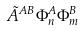<formula> <loc_0><loc_0><loc_500><loc_500>\tilde { A } ^ { A B } \Phi _ { n } ^ { A } \Phi _ { m } ^ { B }</formula> 